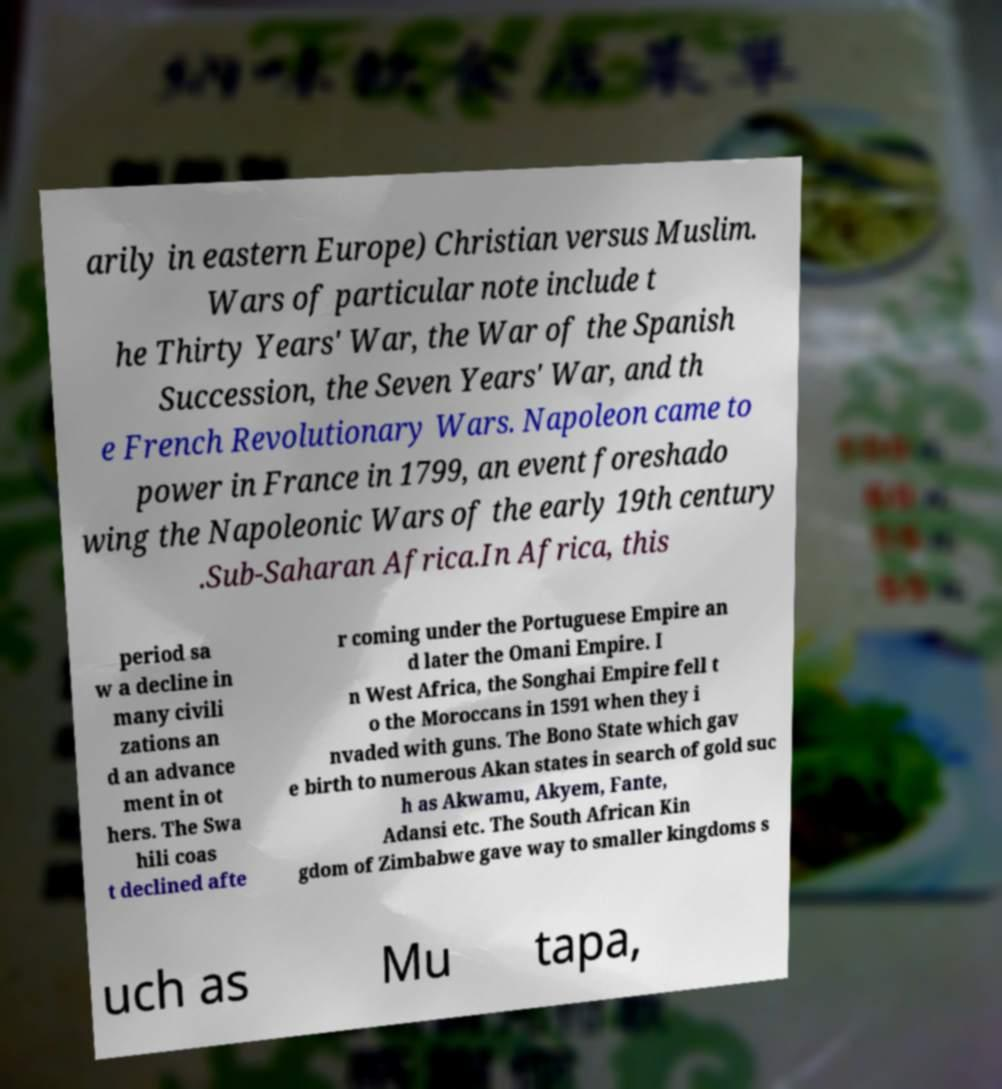Please identify and transcribe the text found in this image. arily in eastern Europe) Christian versus Muslim. Wars of particular note include t he Thirty Years' War, the War of the Spanish Succession, the Seven Years' War, and th e French Revolutionary Wars. Napoleon came to power in France in 1799, an event foreshado wing the Napoleonic Wars of the early 19th century .Sub-Saharan Africa.In Africa, this period sa w a decline in many civili zations an d an advance ment in ot hers. The Swa hili coas t declined afte r coming under the Portuguese Empire an d later the Omani Empire. I n West Africa, the Songhai Empire fell t o the Moroccans in 1591 when they i nvaded with guns. The Bono State which gav e birth to numerous Akan states in search of gold suc h as Akwamu, Akyem, Fante, Adansi etc. The South African Kin gdom of Zimbabwe gave way to smaller kingdoms s uch as Mu tapa, 